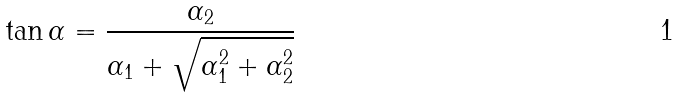<formula> <loc_0><loc_0><loc_500><loc_500>\tan \alpha = \frac { \alpha _ { 2 } } { \alpha _ { 1 } + \sqrt { \alpha ^ { 2 } _ { 1 } + \alpha ^ { 2 } _ { 2 } } }</formula> 